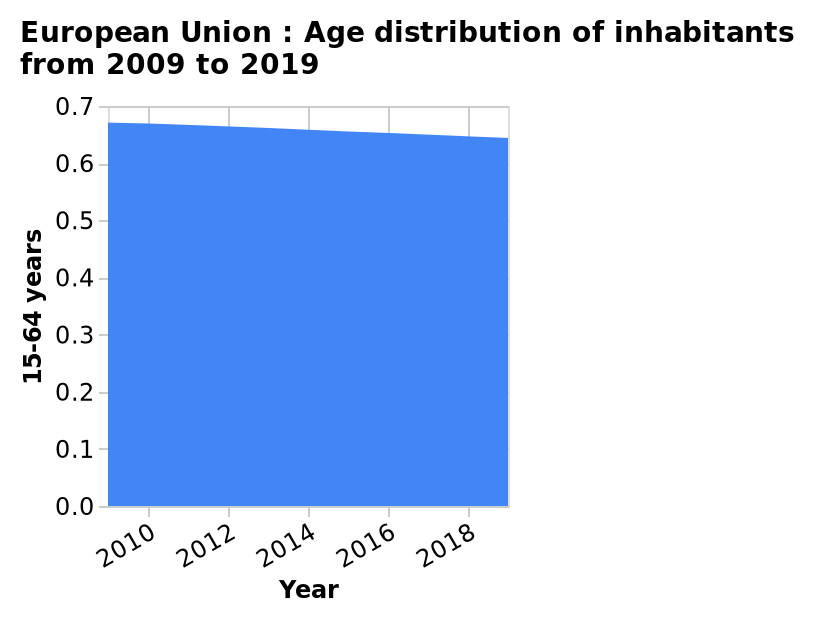<image>
What does the x-axis represent in the area diagram?  The x-axis in the area diagram represents the years from 2009 to 2019. What is the time period covered in the area diagram? The area diagram covers the time period from 2009 to 2019. What is the subject of the area diagram?  The subject of the area diagram is the age distribution of inhabitants in the European Union. What is the title of the area diagram?  The title of the area diagram is "European Union: Age distribution of inhabitants from 2009 to 2019." What does the y-axis represent in the area diagram?  The y-axis in the area diagram represents the age group of 15-64 years. Does the x-axis in the area diagram represent the years from 2008 to 2020? No. The x-axis in the area diagram represents the years from 2009 to 2019. 